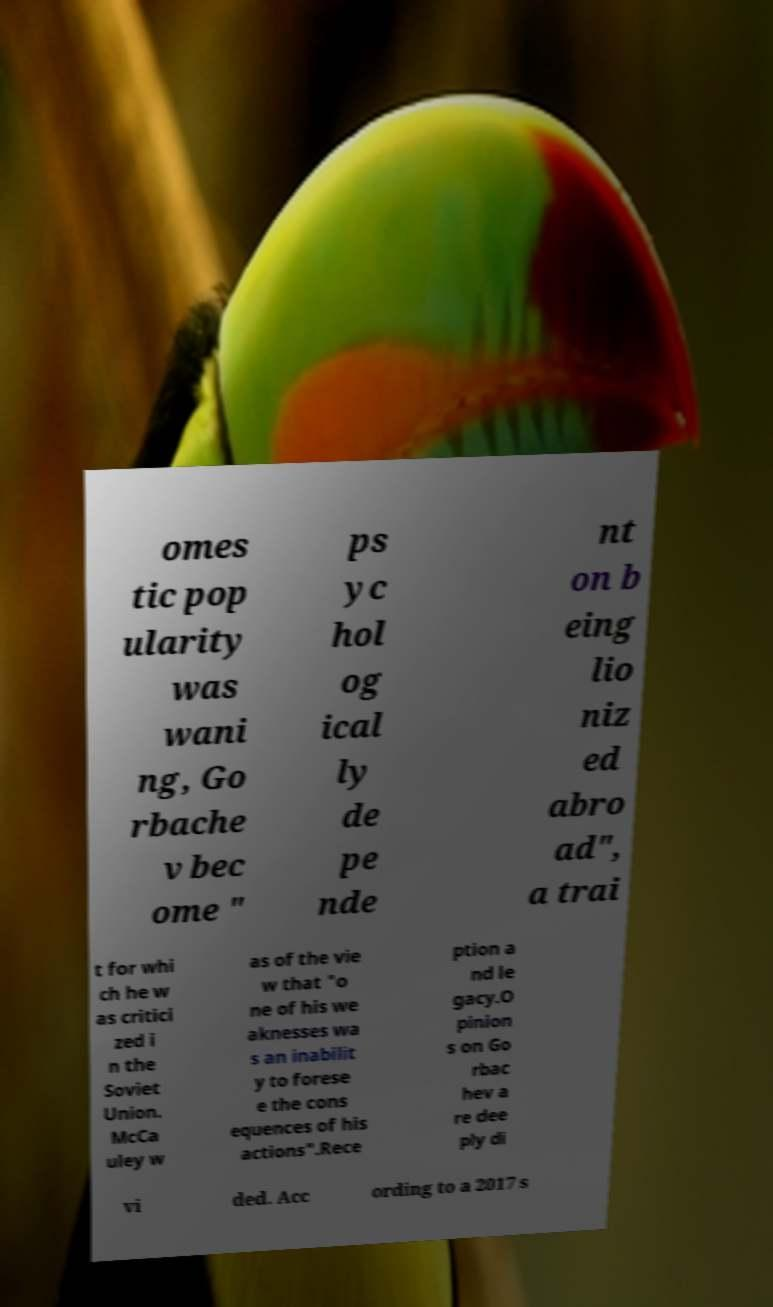Please identify and transcribe the text found in this image. omes tic pop ularity was wani ng, Go rbache v bec ome " ps yc hol og ical ly de pe nde nt on b eing lio niz ed abro ad", a trai t for whi ch he w as critici zed i n the Soviet Union. McCa uley w as of the vie w that "o ne of his we aknesses wa s an inabilit y to forese e the cons equences of his actions".Rece ption a nd le gacy.O pinion s on Go rbac hev a re dee ply di vi ded. Acc ording to a 2017 s 